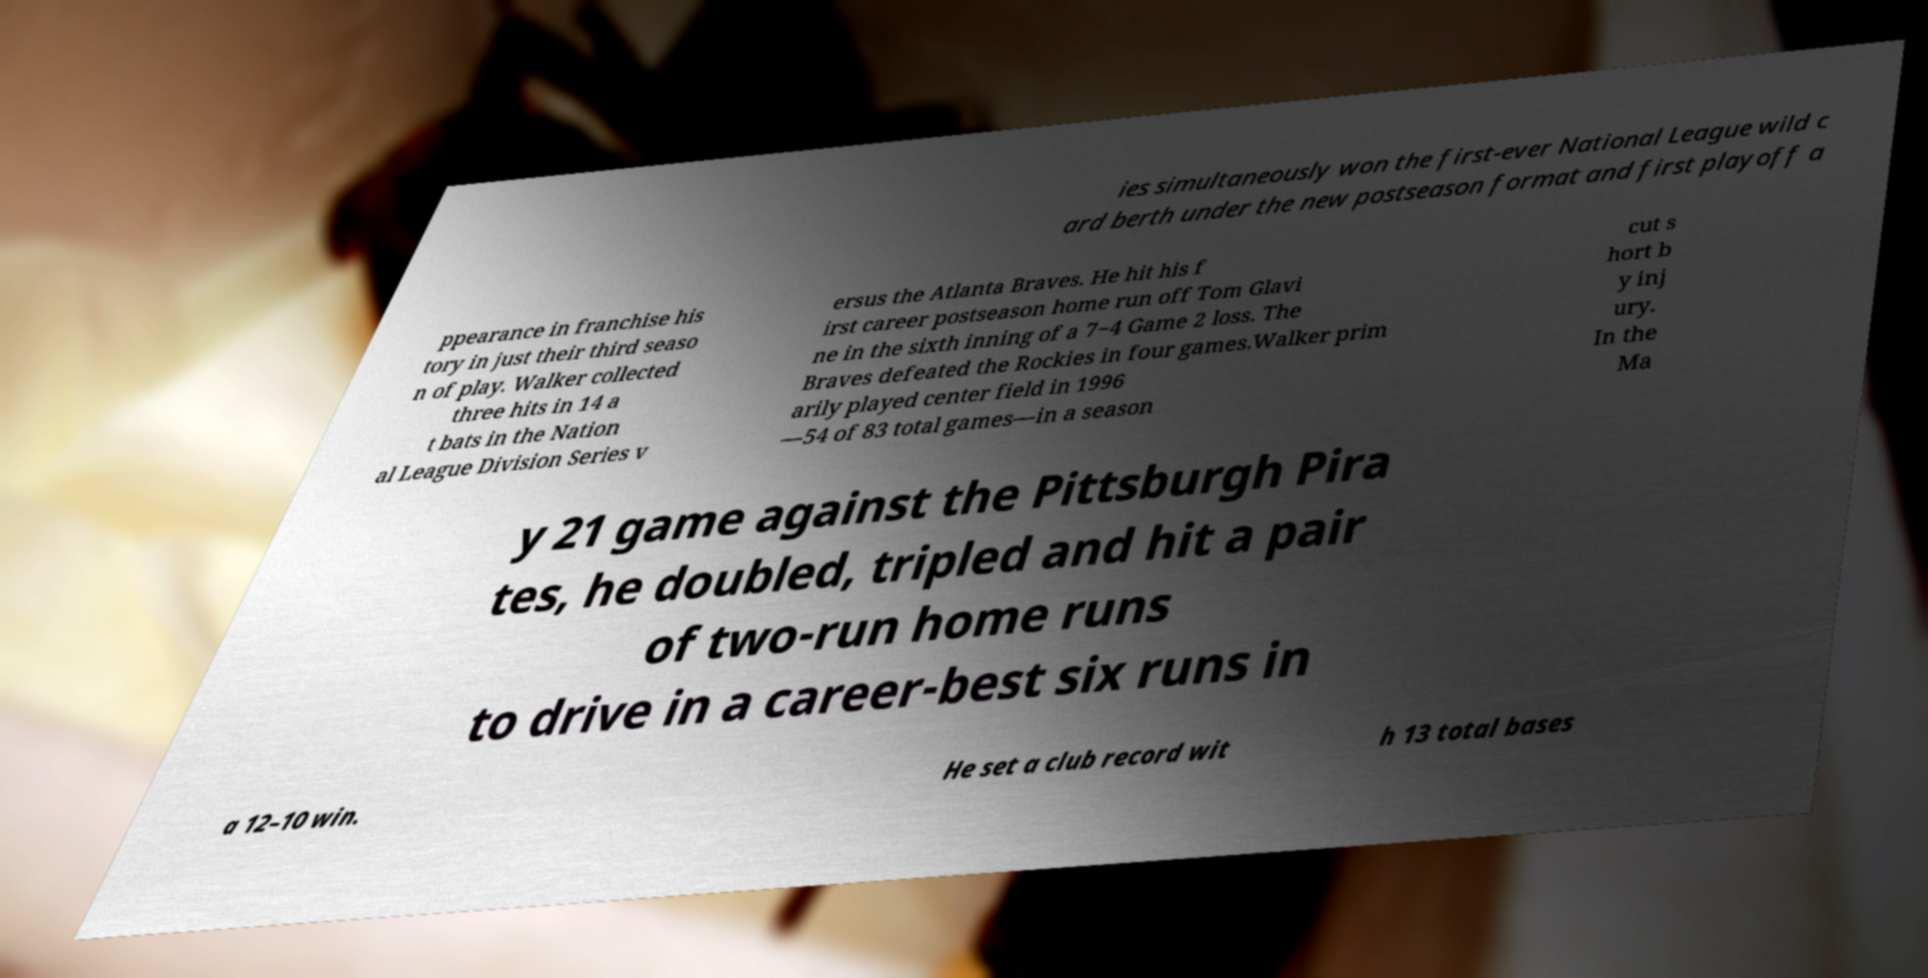For documentation purposes, I need the text within this image transcribed. Could you provide that? ies simultaneously won the first-ever National League wild c ard berth under the new postseason format and first playoff a ppearance in franchise his tory in just their third seaso n of play. Walker collected three hits in 14 a t bats in the Nation al League Division Series v ersus the Atlanta Braves. He hit his f irst career postseason home run off Tom Glavi ne in the sixth inning of a 7−4 Game 2 loss. The Braves defeated the Rockies in four games.Walker prim arily played center field in 1996 —54 of 83 total games—in a season cut s hort b y inj ury. In the Ma y 21 game against the Pittsburgh Pira tes, he doubled, tripled and hit a pair of two-run home runs to drive in a career-best six runs in a 12–10 win. He set a club record wit h 13 total bases 